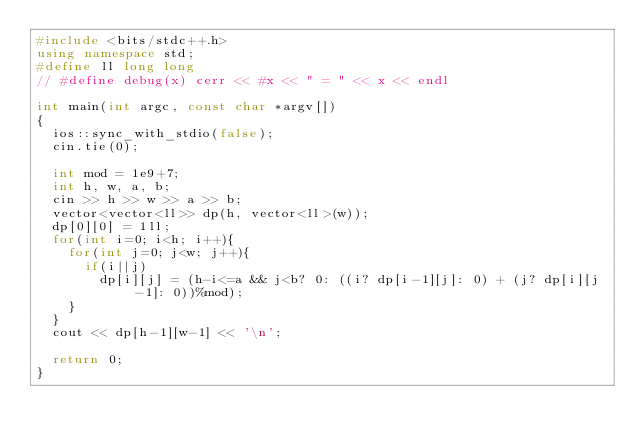Convert code to text. <code><loc_0><loc_0><loc_500><loc_500><_C++_>#include <bits/stdc++.h>
using namespace std;
#define ll long long
// #define debug(x) cerr << #x << " = " << x << endl

int main(int argc, const char *argv[])
{
	ios::sync_with_stdio(false);
	cin.tie(0);
 
	int mod = 1e9+7;
	int h, w, a, b;
	cin >> h >> w >> a >> b;
	vector<vector<ll>> dp(h, vector<ll>(w));
	dp[0][0] = 1ll;
	for(int i=0; i<h; i++){
		for(int j=0; j<w; j++){
			if(i||j)
				dp[i][j] = (h-i<=a && j<b? 0: ((i? dp[i-1][j]: 0) + (j? dp[i][j-1]: 0))%mod);
		}
	}
	cout << dp[h-1][w-1] << '\n';
	
	return 0;
}</code> 